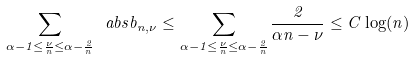Convert formula to latex. <formula><loc_0><loc_0><loc_500><loc_500>\sum _ { \alpha - 1 \leq \frac { \nu } { n } \leq \alpha - \frac { 2 } { n } } \ a b s { b _ { n , \nu } } \leq \sum _ { \alpha - 1 \leq \frac { \nu } { n } \leq \alpha - \frac { 2 } { n } } \frac { 2 } { \alpha n - \nu } \leq C \log ( n )</formula> 